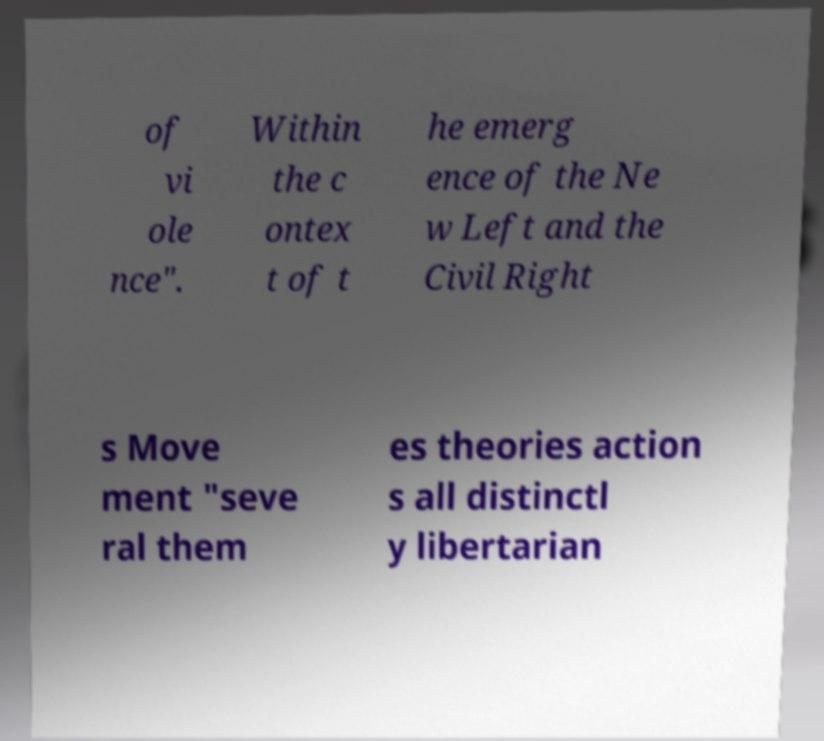Please read and relay the text visible in this image. What does it say? of vi ole nce". Within the c ontex t of t he emerg ence of the Ne w Left and the Civil Right s Move ment "seve ral them es theories action s all distinctl y libertarian 